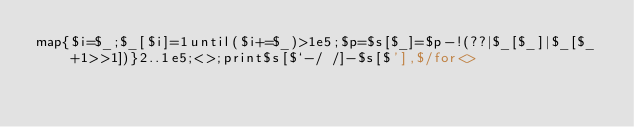<code> <loc_0><loc_0><loc_500><loc_500><_Perl_>map{$i=$_;$_[$i]=1until($i+=$_)>1e5;$p=$s[$_]=$p-!(??|$_[$_]|$_[$_+1>>1])}2..1e5;<>;print$s[$`-/ /]-$s[$'],$/for<></code> 